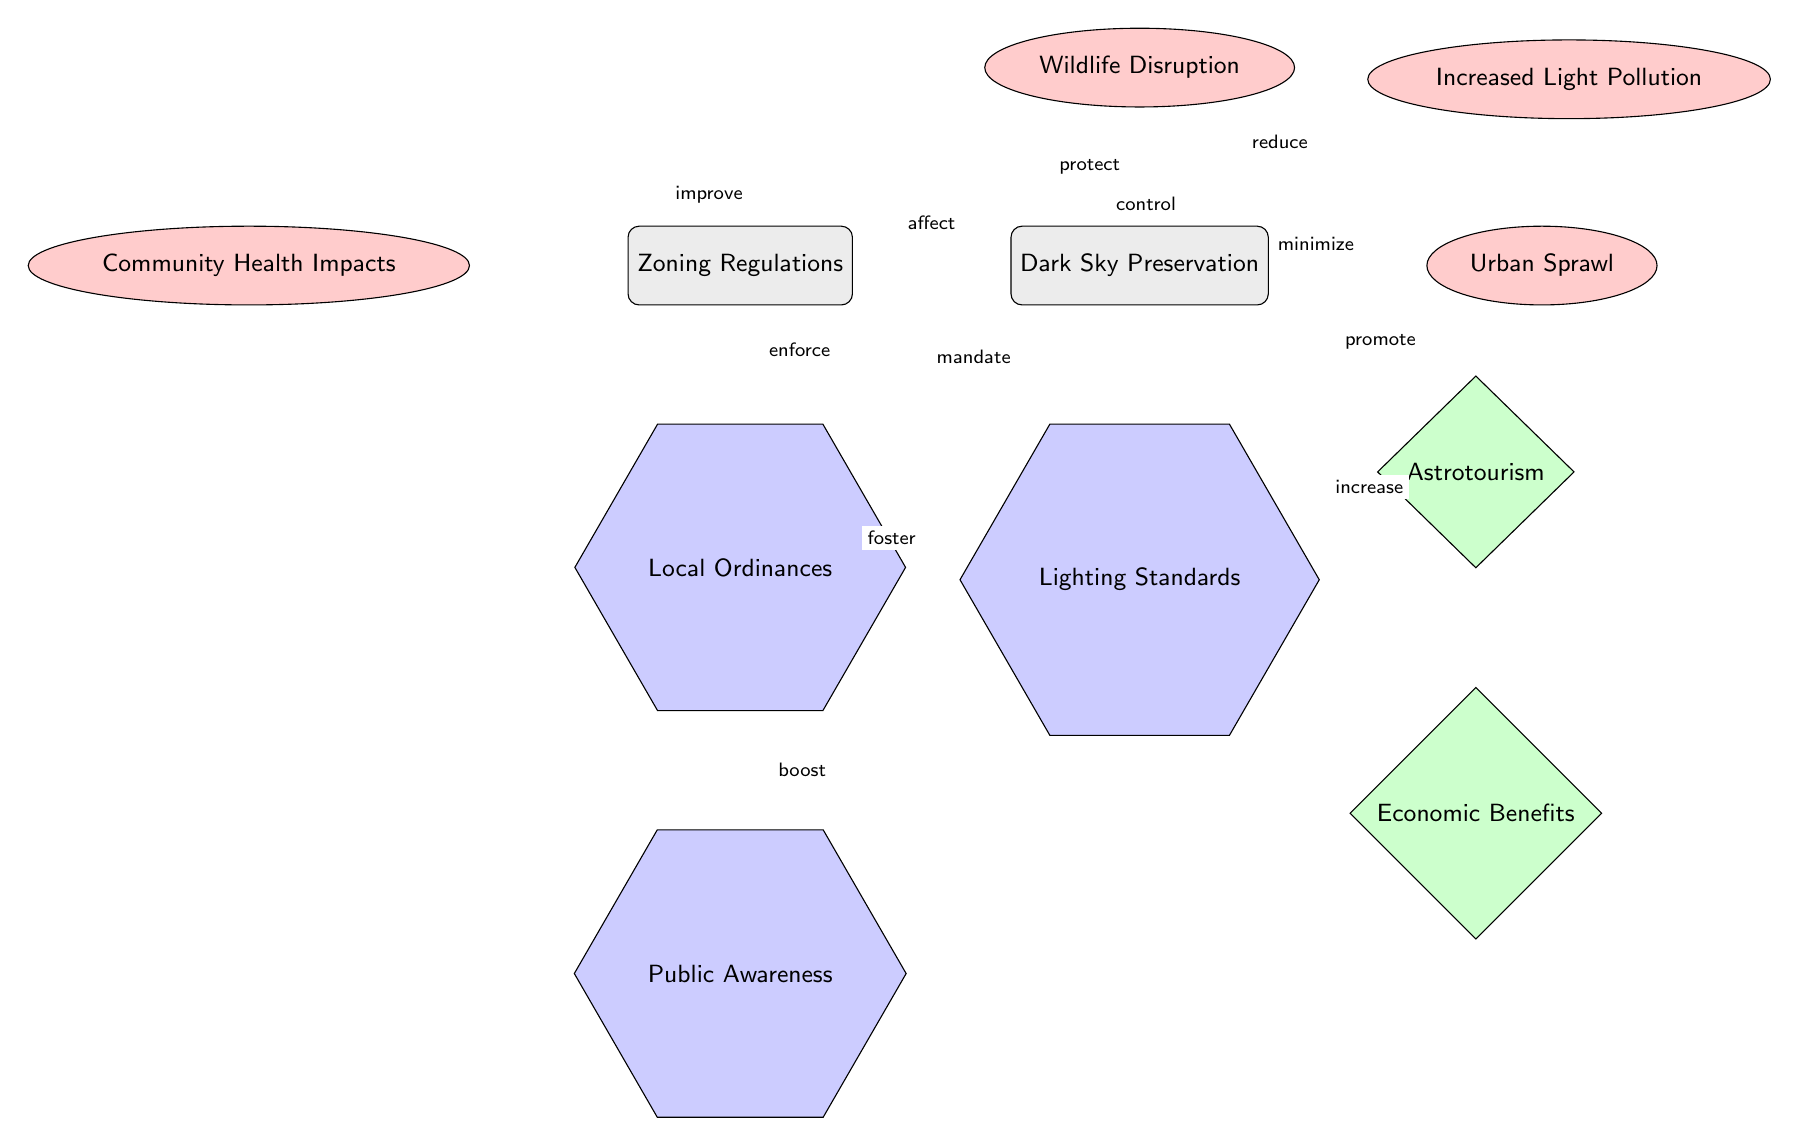What are the issues linked to zoning regulations? The diagram shows multiple issues associated with zoning regulations, including increased light pollution, urban sprawl, wildlife disruption, and community health impacts.
Answer: Increased light pollution, urban sprawl, wildlife disruption, community health impacts How many benefits are shown in relation to dark sky preservation? The diagram illustrates two benefits related to dark sky preservation: astrotourism and economic benefits. Thus, counting the nodes under benefits provides the answer.
Answer: 2 What is the relationship between dark sky preservation and wildlife? The diagram indicates a protective relationship where dark sky preservation is linked to wildlife protection, as denoted by the label "protect."
Answer: Protect What solution directly affects public awareness? The diagram specifies that local ordinances boost public awareness, indicating a direct relationship. This relationship is shown through the edge labeled "boost."
Answer: Local ordinances What issue is directly connected to dark sky and light pollution? The diagram illustrates a direct connection where dark sky preservation is linked to minimizing light pollution, as indicated by the edge labeled "minimize."
Answer: Minimize What are the benefits of preserving dark sky areas? According to the diagram, the benefits highlighted are astrotourism, which can promote tourism, and economic benefits, which may arise from increased activities related to dark sky areas.
Answer: Astrotourism, Economic Benefits Which zoning solution mandates the enforcement of lighting standards? The diagram points out that zoning regulations enforce lighting standards, establishing how these regulations impact the solutions proposed in the context of dark sky preservation.
Answer: Mandate How does zoning regulation affect urban sprawl? The diagram indicates that zoning regulations control urban sprawl, thereby establishing a relationship that encompasses the impact of zoning on the spread of urban areas.
Answer: Control What two solutions are indicated to have a cumulative effect on dark sky areas? The diagram illustrates that both public awareness and local ordinances foster dark sky preservation, indicating an interaction between these two solutions.
Answer: Public awareness, Local ordinances 